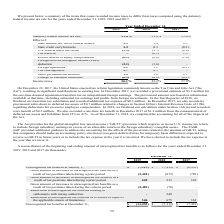According to Manhattan Associates's financial document, What is the unrecognised tax benefits as of December 31, 2019? Based on the financial document, the answer is 11.2 (in millions). Also, What is the reason for unrecognised tax benefits decreasing by 3.1 million in 2020? Based on the financial document, the answer is Due to the expiration of statutes of limitations in multiple jurisdictions globally. Also, What is the recognised income tax expense in 2017? According to the financial document, 0.3 (in millions). The relevant text states: "State credit carryforwards 1.3 0.3 (0.1 )..." Also, can you calculate: What is the change in unrecognised tax benefits between December 31, 2019 and 2018? Based on the calculation: 11,239-7,113, the result is 4126 (in thousands). This is based on the information: "nized tax benefits at December 31, $ (11,239 ) $ (7,113 ) $ (7,419 ) Unrecognized tax benefits at December 31, $ (11,239 ) $ (7,113 ) $ (7,419 )..." The key data points involved are: 11,239, 7,113. Also, can you calculate: What is the change in unrecognized tax benefits between the start and end of 2017? Based on the calculation: 7,419-6,938, the result is 481 (in thousands). This is based on the information: "cognized tax benefits at January 1, $ (7,113 ) $ (7,419 ) $ (6,938 ) x benefits at January 1, $ (7,113 ) $ (7,419 ) $ (6,938 )..." The key data points involved are: 6,938, 7,419. Also, can you calculate: What is the change in unrecognised tax benefits between 2019 and 2017 year end? Based on the calculation: 11,239-7,419, the result is 3820 (in thousands). This is based on the information: "enefits at December 31, $ (11,239 ) $ (7,113 ) $ (7,419 ) Unrecognized tax benefits at December 31, $ (11,239 ) $ (7,113 ) $ (7,419 )..." The key data points involved are: 11,239, 7,419. 